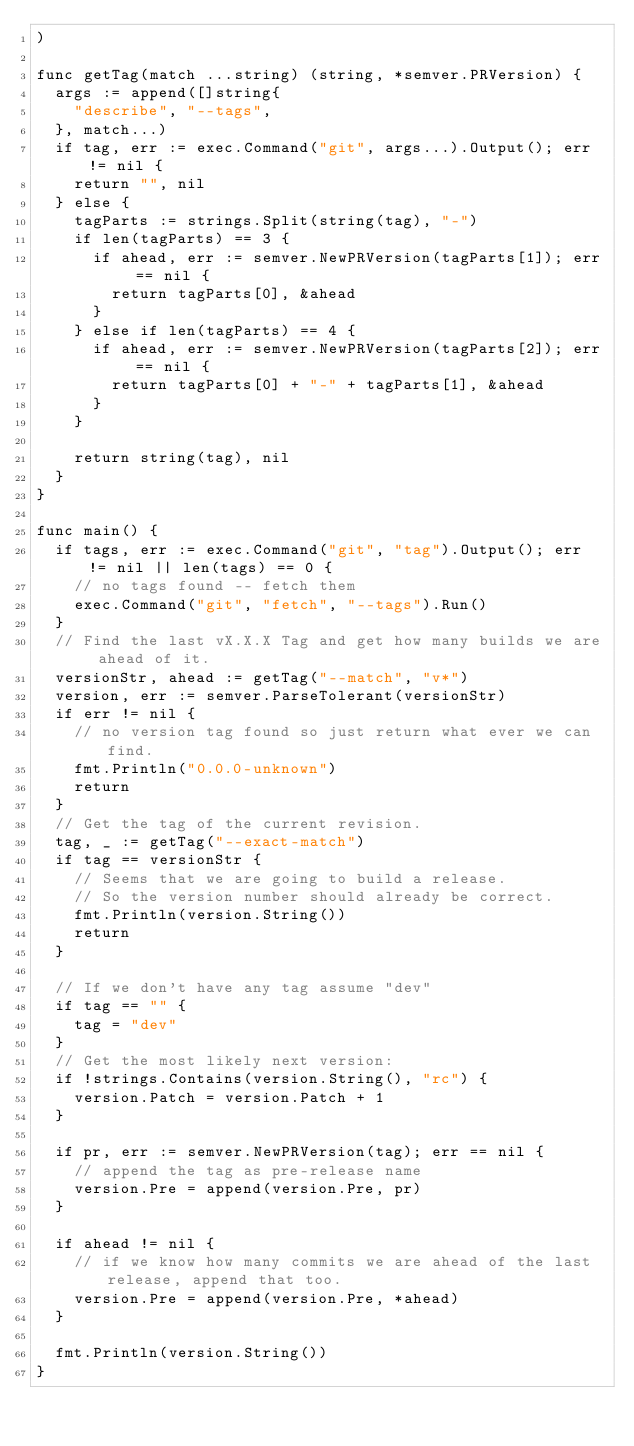<code> <loc_0><loc_0><loc_500><loc_500><_Go_>)

func getTag(match ...string) (string, *semver.PRVersion) {
	args := append([]string{
		"describe", "--tags",
	}, match...)
	if tag, err := exec.Command("git", args...).Output(); err != nil {
		return "", nil
	} else {
		tagParts := strings.Split(string(tag), "-")
		if len(tagParts) == 3 {
			if ahead, err := semver.NewPRVersion(tagParts[1]); err == nil {
				return tagParts[0], &ahead
			}
		} else if len(tagParts) == 4 {
			if ahead, err := semver.NewPRVersion(tagParts[2]); err == nil {
				return tagParts[0] + "-" + tagParts[1], &ahead
			}
		}

		return string(tag), nil
	}
}

func main() {
	if tags, err := exec.Command("git", "tag").Output(); err != nil || len(tags) == 0 {
		// no tags found -- fetch them
		exec.Command("git", "fetch", "--tags").Run()
	}
	// Find the last vX.X.X Tag and get how many builds we are ahead of it.
	versionStr, ahead := getTag("--match", "v*")
	version, err := semver.ParseTolerant(versionStr)
	if err != nil {
		// no version tag found so just return what ever we can find.
		fmt.Println("0.0.0-unknown")
		return
	}
	// Get the tag of the current revision.
	tag, _ := getTag("--exact-match")
	if tag == versionStr {
		// Seems that we are going to build a release.
		// So the version number should already be correct.
		fmt.Println(version.String())
		return
	}

	// If we don't have any tag assume "dev"
	if tag == "" {
		tag = "dev"
	}
	// Get the most likely next version:
	if !strings.Contains(version.String(), "rc") {
		version.Patch = version.Patch + 1
	}

	if pr, err := semver.NewPRVersion(tag); err == nil {
		// append the tag as pre-release name
		version.Pre = append(version.Pre, pr)
	}

	if ahead != nil {
		// if we know how many commits we are ahead of the last release, append that too.
		version.Pre = append(version.Pre, *ahead)
	}

	fmt.Println(version.String())
}
</code> 